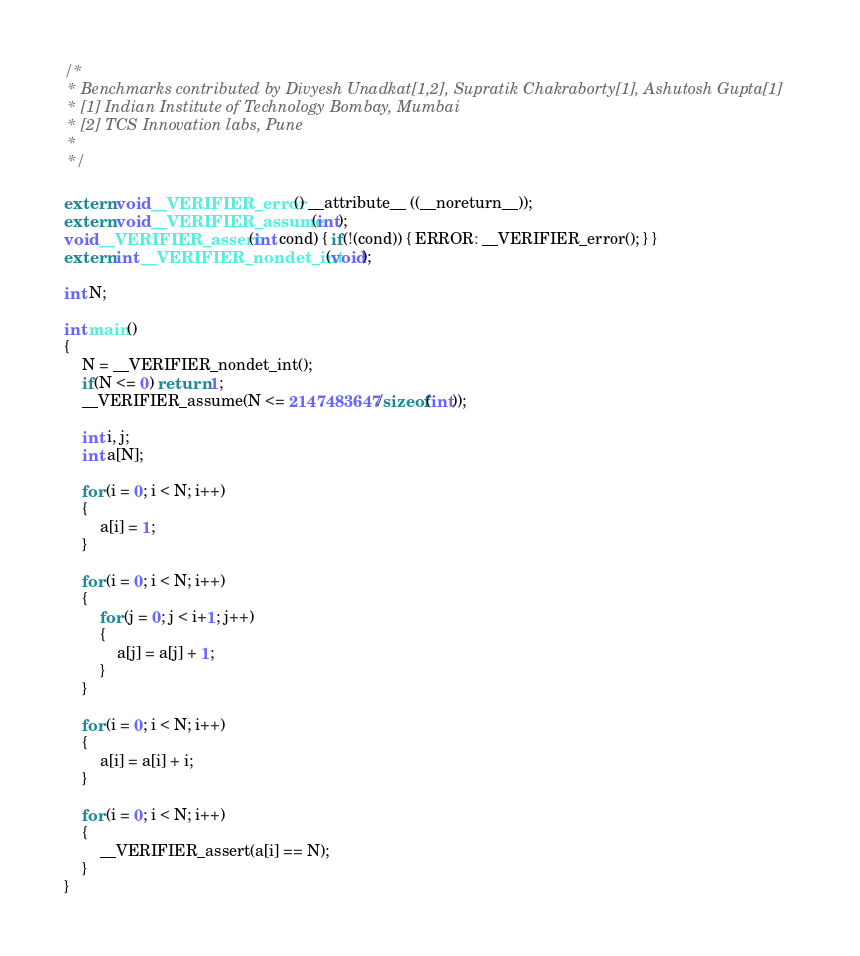Convert code to text. <code><loc_0><loc_0><loc_500><loc_500><_C_>/*
 * Benchmarks contributed by Divyesh Unadkat[1,2], Supratik Chakraborty[1], Ashutosh Gupta[1]
 * [1] Indian Institute of Technology Bombay, Mumbai
 * [2] TCS Innovation labs, Pune
 *
 */

extern void __VERIFIER_error() __attribute__ ((__noreturn__));
extern void __VERIFIER_assume(int);
void __VERIFIER_assert(int cond) { if(!(cond)) { ERROR: __VERIFIER_error(); } }
extern int __VERIFIER_nondet_int(void);

int N;

int main()
{
	N = __VERIFIER_nondet_int();
	if(N <= 0) return 1;
	__VERIFIER_assume(N <= 2147483647/sizeof(int));

	int i, j;
	int a[N];

	for (i = 0; i < N; i++)
	{
		a[i] = 1;
	}

	for (i = 0; i < N; i++)
	{
		for (j = 0; j < i+1; j++)
		{
			a[j] = a[j] + 1;
		}
	}

	for (i = 0; i < N; i++)
	{
		a[i] = a[i] + i;
	}

	for (i = 0; i < N; i++)
	{
		__VERIFIER_assert(a[i] == N);
	}
}


</code> 